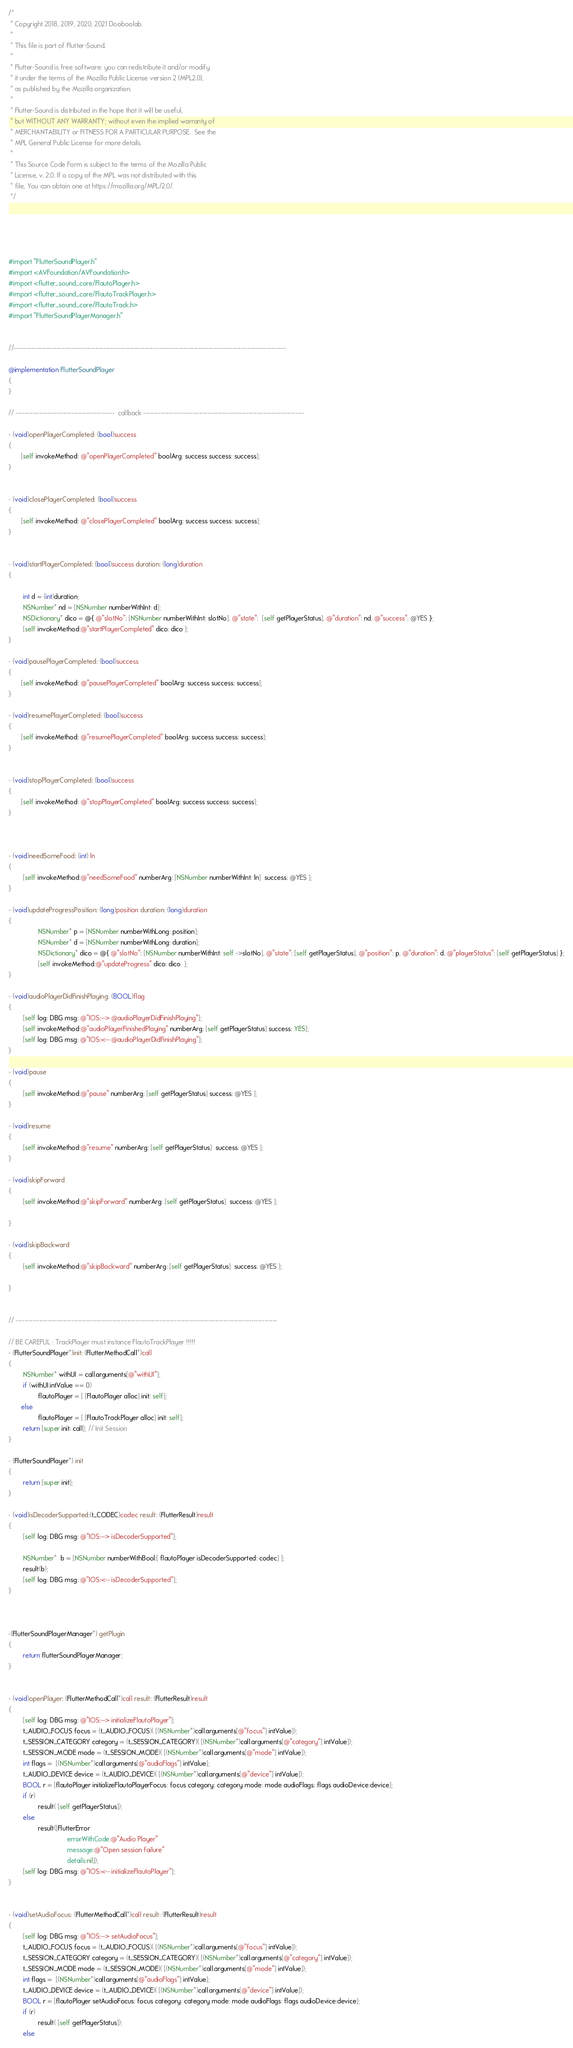Convert code to text. <code><loc_0><loc_0><loc_500><loc_500><_ObjectiveC_>/*
 * Copyright 2018, 2019, 2020, 2021 Dooboolab.
 *
 * This file is part of Flutter-Sound.
 *
 * Flutter-Sound is free software: you can redistribute it and/or modify
 * it under the terms of the Mozilla Public License version 2 (MPL2.0),
 * as published by the Mozilla organization.
 *
 * Flutter-Sound is distributed in the hope that it will be useful,
 * but WITHOUT ANY WARRANTY; without even the implied warranty of
 * MERCHANTABILITY or FITNESS FOR A PARTICULAR PURPOSE.  See the
 * MPL General Public License for more details.
 *
 * This Source Code Form is subject to the terms of the Mozilla Public
 * License, v. 2.0. If a copy of the MPL was not distributed with this
 * file, You can obtain one at https://mozilla.org/MPL/2.0/.
 */





#import "FlutterSoundPlayer.h"
#import <AVFoundation/AVFoundation.h>
#import <flutter_sound_core/FlautoPlayer.h>
#import <flutter_sound_core/FlautoTrackPlayer.h>
#import <flutter_sound_core/FlautoTrack.h>
#import "FlutterSoundPlayerManager.h"
         
 
//-------------------------------------------------------------------------------------------------------------------------------

@implementation FlutterSoundPlayer
{
}

// ----------------------------------------------  callback ---------------------------------------------------------------------------

- (void)openPlayerCompleted: (bool)success
{
       [self invokeMethod: @"openPlayerCompleted" boolArg: success success: success];
}


- (void)closePlayerCompleted: (bool)success
{
       [self invokeMethod: @"closePlayerCompleted" boolArg: success success: success];
}


- (void)startPlayerCompleted: (bool)success duration: (long)duration
{
     
        int d = (int)duration;
        NSNumber* nd = [NSNumber numberWithInt: d];
        NSDictionary* dico = @{ @"slotNo": [NSNumber numberWithInt: slotNo], @"state":  [self getPlayerStatus], @"duration": nd, @"success": @YES };
        [self invokeMethod:@"startPlayerCompleted" dico: dico ];
}

- (void)pausePlayerCompleted: (bool)success
{
       [self invokeMethod: @"pausePlayerCompleted" boolArg: success success: success];
}

- (void)resumePlayerCompleted: (bool)success
{
       [self invokeMethod: @"resumePlayerCompleted" boolArg: success success: success];
}


- (void)stopPlayerCompleted: (bool)success
{
       [self invokeMethod: @"stopPlayerCompleted" boolArg: success success: success];
}



- (void)needSomeFood: (int) ln
{
        [self invokeMethod:@"needSomeFood" numberArg: [NSNumber numberWithInt: ln]  success: @YES ];
}

- (void)updateProgressPosition: (long)position duration: (long)duration
{
                NSNumber* p = [NSNumber numberWithLong: position];
                NSNumber* d = [NSNumber numberWithLong: duration];
                NSDictionary* dico = @{ @"slotNo": [NSNumber numberWithInt: self ->slotNo], @"state": [self getPlayerStatus], @"position": p, @"duration": d, @"playerStatus": [self getPlayerStatus] };
                [self invokeMethod:@"updateProgress" dico: dico  ];
}

- (void)audioPlayerDidFinishPlaying: (BOOL)flag
{
        [self log: DBG msg: @"IOS:--> @audioPlayerDidFinishPlaying"];
        [self invokeMethod:@"audioPlayerFinishedPlaying" numberArg: [self getPlayerStatus] success: YES];
        [self log: DBG msg: @"IOS:<-- @audioPlayerDidFinishPlaying"];
}

- (void)pause
{
        [self invokeMethod:@"pause" numberArg: [self getPlayerStatus] success: @YES ];
}

- (void)resume
{
        [self invokeMethod:@"resume" numberArg: [self getPlayerStatus]  success: @YES ];
}

- (void)skipForward
{
        [self invokeMethod:@"skipForward" numberArg: [self getPlayerStatus]  success: @YES ];

}

- (void)skipBackward
{
        [self invokeMethod:@"skipBackward" numberArg: [self getPlayerStatus]  success: @YES ];

}


// --------------------------------------------------------------------------------------------------------------------------

// BE CAREFUL : TrackPlayer must instance FlautoTrackPlayer !!!!!
- (FlutterSoundPlayer*)init: (FlutterMethodCall*)call
{
        NSNumber* withUI = call.arguments[@"withUI"];
        if (withUI.intValue == 0)
                flautoPlayer = [ [FlautoPlayer alloc] init: self];
       else
                flautoPlayer = [ [FlautoTrackPlayer alloc] init: self];
        return [super init: call]; // Init Session
}

- (FlutterSoundPlayer*) init
{
        return [super init];
}

- (void)isDecoderSupported:(t_CODEC)codec result: (FlutterResult)result
{
        [self log: DBG msg: @"IOS:--> isDecoderSupported"];

        NSNumber*  b = [NSNumber numberWithBool:[ flautoPlayer isDecoderSupported: codec] ];
        result(b);
        [self log: DBG msg: @"IOS:<-- isDecoderSupported"];
}



-(FlutterSoundPlayerManager*) getPlugin
{
        return flutterSoundPlayerManager;
}


- (void)openPlayer: (FlutterMethodCall*)call result: (FlutterResult)result
{
        [self log: DBG msg: @"IOS:--> initializeFlautoPlayer"];
        t_AUDIO_FOCUS focus = (t_AUDIO_FOCUS)( [(NSNumber*)call.arguments[@"focus"] intValue]);
        t_SESSION_CATEGORY category = (t_SESSION_CATEGORY)( [(NSNumber*)call.arguments[@"category"] intValue]);
        t_SESSION_MODE mode = (t_SESSION_MODE)( [(NSNumber*)call.arguments[@"mode"] intValue]);
        int flags =  [(NSNumber*)call.arguments[@"audioFlags"] intValue];
        t_AUDIO_DEVICE device = (t_AUDIO_DEVICE)( [(NSNumber*)call.arguments[@"device"] intValue]);
        BOOL r = [flautoPlayer initializeFlautoPlayerFocus: focus category: category mode: mode audioFlags: flags audioDevice:device];
        if (r)
                result( [self getPlayerStatus]);
        else
                result([FlutterError
                                errorWithCode:@"Audio Player"
                                message:@"Open session failure"
                                details:nil]);
        [self log: DBG msg: @"IOS:<-- initializeFlautoPlayer"];
}


- (void)setAudioFocus: (FlutterMethodCall*)call result: (FlutterResult)result
{
        [self log: DBG msg: @"IOS:--> setAudioFocus"];
        t_AUDIO_FOCUS focus = (t_AUDIO_FOCUS)( [(NSNumber*)call.arguments[@"focus"] intValue]);
        t_SESSION_CATEGORY category = (t_SESSION_CATEGORY)( [(NSNumber*)call.arguments[@"category"] intValue]);
        t_SESSION_MODE mode = (t_SESSION_MODE)( [(NSNumber*)call.arguments[@"mode"] intValue]);
        int flags =  [(NSNumber*)call.arguments[@"audioFlags"] intValue];
        t_AUDIO_DEVICE device = (t_AUDIO_DEVICE)( [(NSNumber*)call.arguments[@"device"] intValue]);
        BOOL r = [flautoPlayer setAudioFocus: focus category: category mode: mode audioFlags: flags audioDevice:device];
        if (r)
                result( [self getPlayerStatus]);
        else</code> 